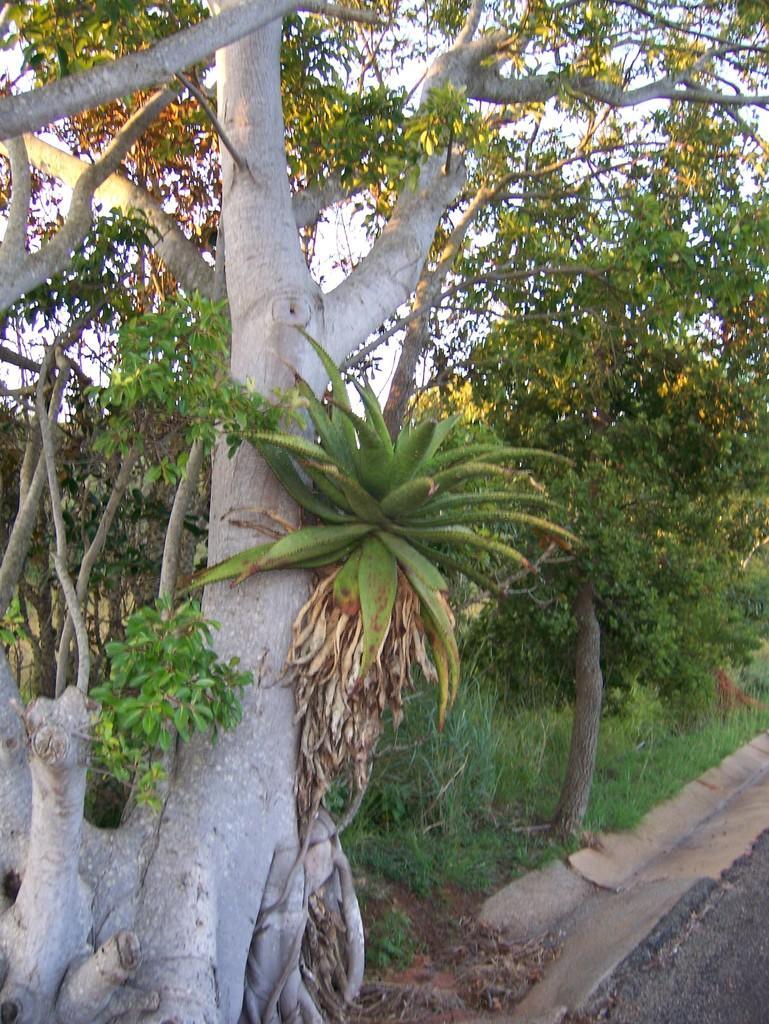How would you summarize this image in a sentence or two? In this image we can see some trees and grass on the ground. 